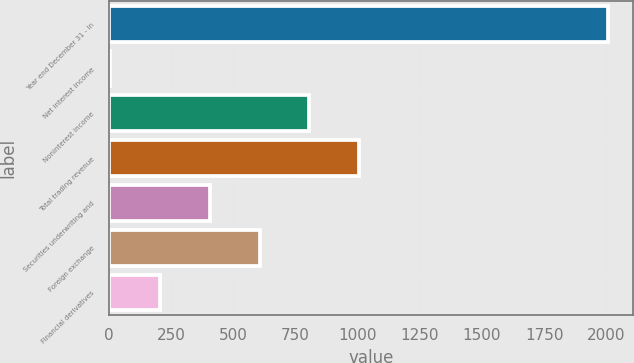Convert chart. <chart><loc_0><loc_0><loc_500><loc_500><bar_chart><fcel>Year end December 31 - in<fcel>Net interest income<fcel>Noninterest income<fcel>Total trading revenue<fcel>Securities underwriting and<fcel>Foreign exchange<fcel>Financial derivatives<nl><fcel>2007<fcel>7<fcel>807<fcel>1007<fcel>407<fcel>607<fcel>207<nl></chart> 